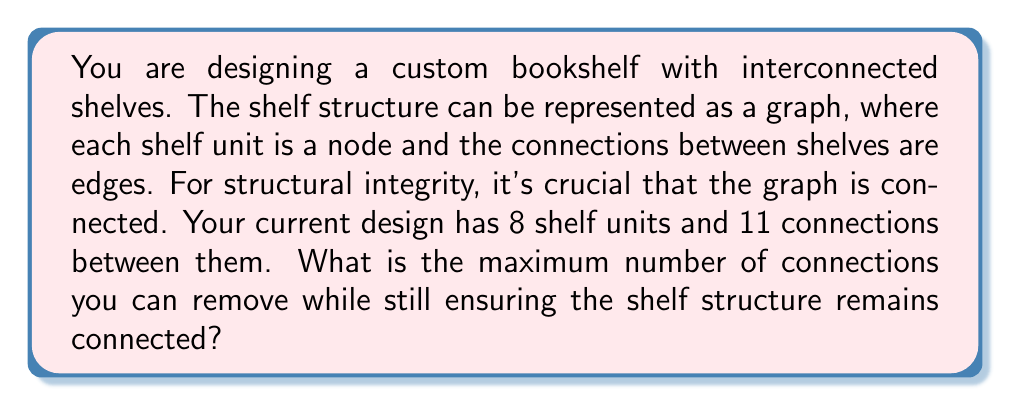Give your solution to this math problem. To solve this problem, we need to use concepts from graph theory, specifically the properties of connected graphs and spanning trees.

1. Let's define our graph $G = (V, E)$, where:
   $V$ = set of vertices (shelf units), $|V| = 8$
   $E$ = set of edges (connections), $|E| = 11$

2. A connected graph with the minimum number of edges is called a spanning tree. A spanning tree for a graph with $n$ vertices has exactly $n-1$ edges.

3. In this case, the minimum number of edges required to keep the graph connected is:
   $$\text{Minimum edges} = |V| - 1 = 8 - 1 = 7$$

4. The number of edges that can be removed while keeping the graph connected is the difference between the current number of edges and the minimum required:
   $$\text{Removable edges} = |E| - (\text{Minimum edges})$$
   $$= 11 - 7 = 4$$

5. This result can be verified using the cyclomatic number (or cycle rank) of the graph, which is the number of independent cycles in the graph:
   $$\text{Cyclomatic number} = |E| - |V| + 1 = 11 - 8 + 1 = 4$$

   This number represents the maximum number of edges that can be removed without disconnecting the graph.

Therefore, you can remove a maximum of 4 connections while ensuring the shelf structure remains connected.
Answer: 4 connections 